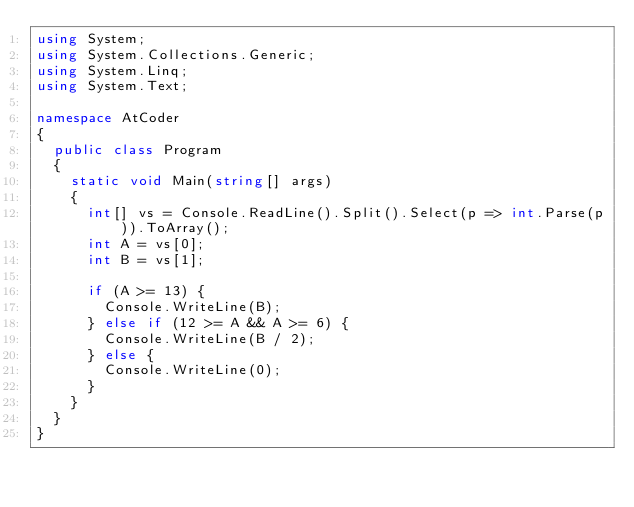<code> <loc_0><loc_0><loc_500><loc_500><_C#_>using System;
using System.Collections.Generic;
using System.Linq;
using System.Text;

namespace AtCoder
{
	public class Program
	{
		static void Main(string[] args)
		{
			int[] vs = Console.ReadLine().Split().Select(p => int.Parse(p)).ToArray();
			int A = vs[0];
			int B = vs[1];

			if (A >= 13) {
				Console.WriteLine(B);
			} else if (12 >= A && A >= 6) {
				Console.WriteLine(B / 2);
			} else {
				Console.WriteLine(0);
			}
		}
	}
}
</code> 